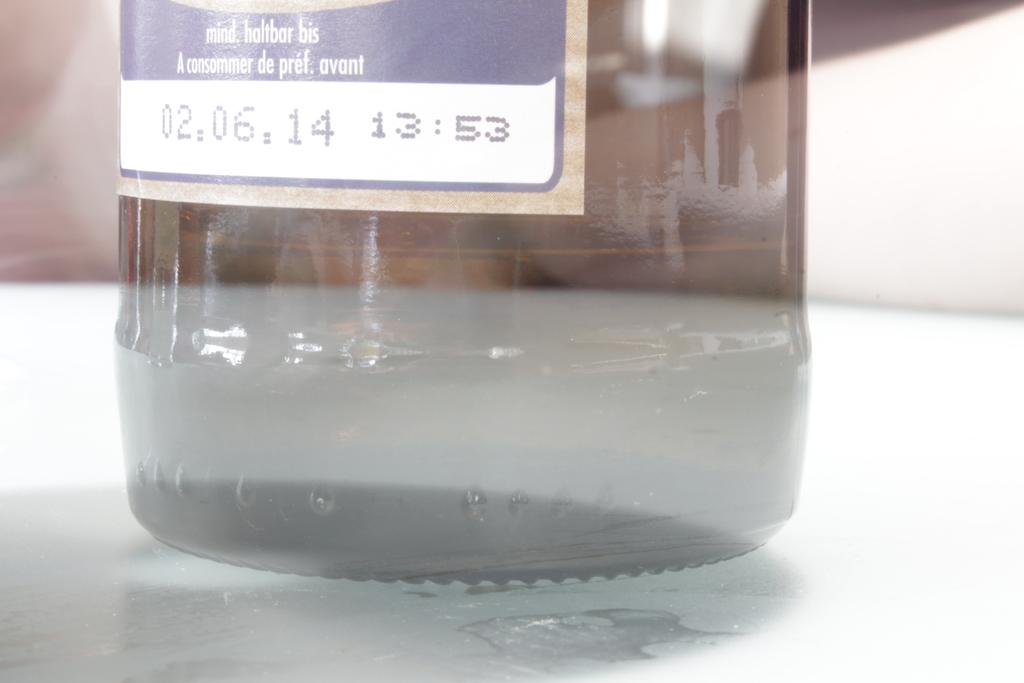<image>
Create a compact narrative representing the image presented. A clear bottle on a table with a date stamp of 02.06.14. 